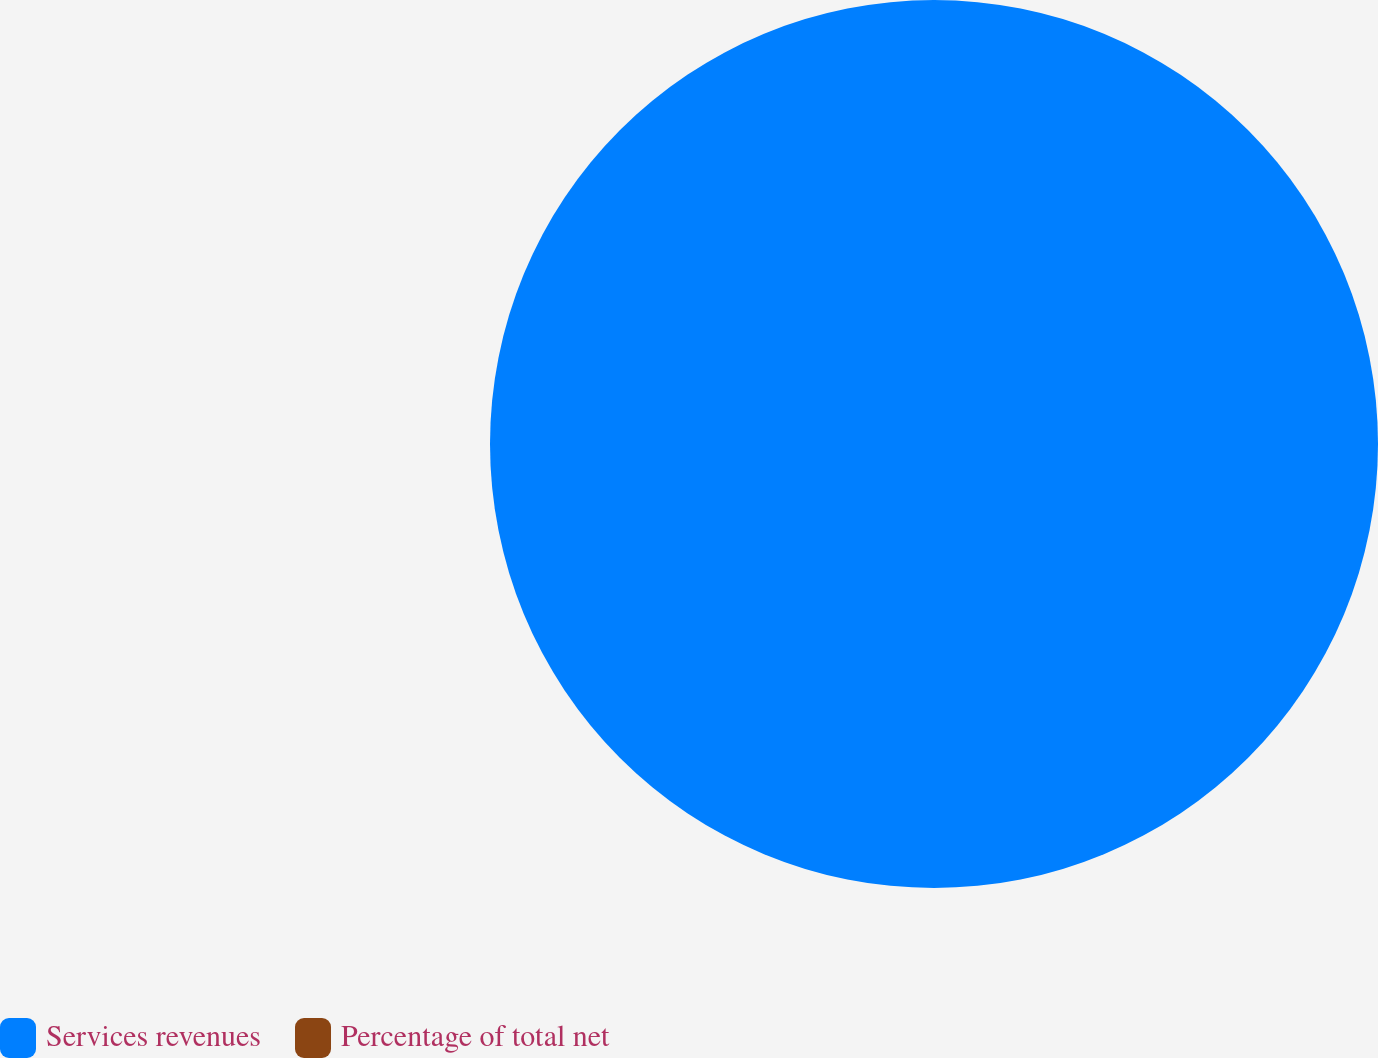Convert chart to OTSL. <chart><loc_0><loc_0><loc_500><loc_500><pie_chart><fcel>Services revenues<fcel>Percentage of total net<nl><fcel>100.0%<fcel>0.0%<nl></chart> 